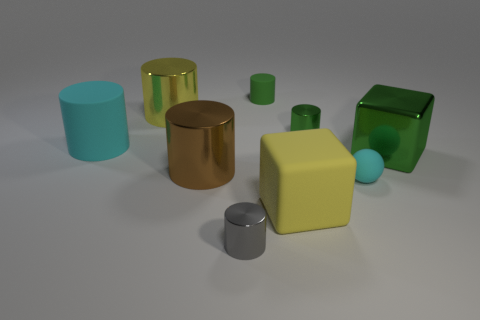Are there fewer tiny metallic things that are right of the gray shiny cylinder than small green shiny things that are in front of the big brown metallic thing?
Make the answer very short. No. Are there any big matte cylinders in front of the gray shiny cylinder?
Your answer should be compact. No. How many things are either matte objects left of the small green shiny cylinder or cyan matte objects that are behind the ball?
Ensure brevity in your answer.  3. How many tiny rubber cylinders have the same color as the big metallic cube?
Ensure brevity in your answer.  1. There is a rubber thing that is the same shape as the large green metal object; what is its color?
Ensure brevity in your answer.  Yellow. What is the shape of the thing that is both in front of the big green metallic object and behind the rubber ball?
Keep it short and to the point. Cylinder. Is the number of big brown objects greater than the number of blue matte things?
Ensure brevity in your answer.  Yes. What material is the big green block?
Your response must be concise. Metal. Are there any other things that are the same size as the green block?
Give a very brief answer. Yes. There is a green matte thing that is the same shape as the big yellow shiny object; what size is it?
Offer a terse response. Small. 